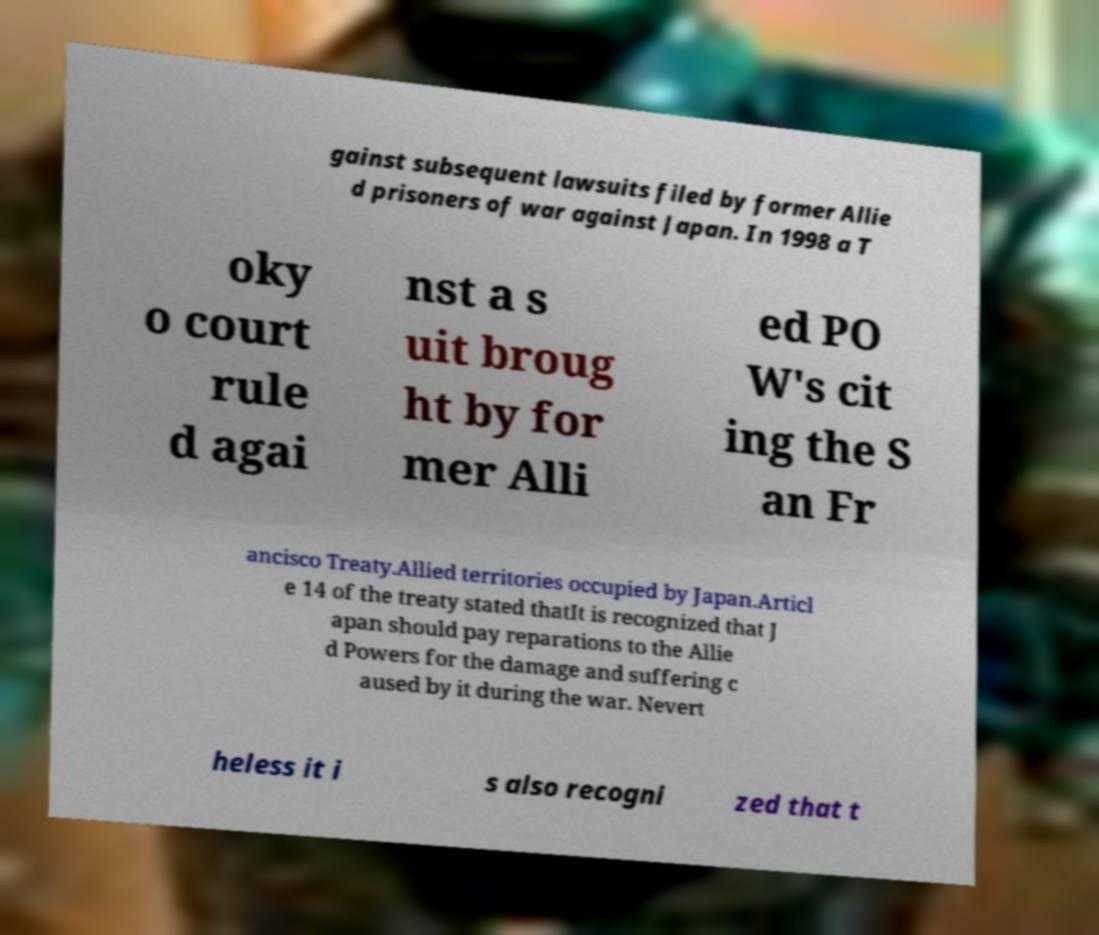Could you extract and type out the text from this image? gainst subsequent lawsuits filed by former Allie d prisoners of war against Japan. In 1998 a T oky o court rule d agai nst a s uit broug ht by for mer Alli ed PO W's cit ing the S an Fr ancisco Treaty.Allied territories occupied by Japan.Articl e 14 of the treaty stated thatIt is recognized that J apan should pay reparations to the Allie d Powers for the damage and suffering c aused by it during the war. Nevert heless it i s also recogni zed that t 